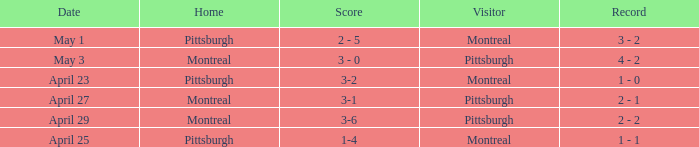When did Montreal visit and have a score of 1-4? April 25. 